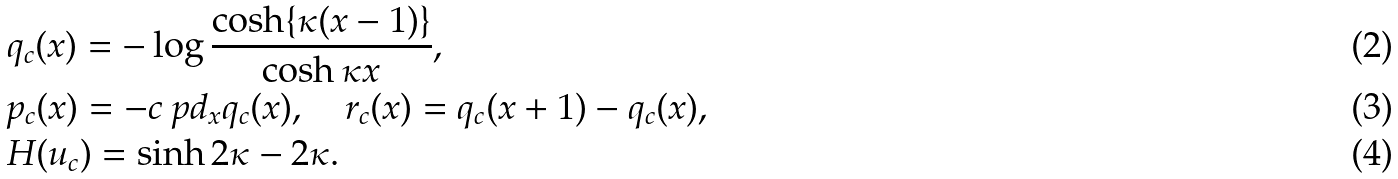Convert formula to latex. <formula><loc_0><loc_0><loc_500><loc_500>& q _ { c } ( x ) = - \log \frac { \cosh \{ \kappa ( x - 1 ) \} } { \cosh \kappa x } , \\ & p _ { c } ( x ) = - c \ p d _ { x } q _ { c } ( x ) , \quad r _ { c } ( x ) = q _ { c } ( x + 1 ) - q _ { c } ( x ) , \\ & H ( u _ { c } ) = \sinh 2 \kappa - 2 \kappa .</formula> 